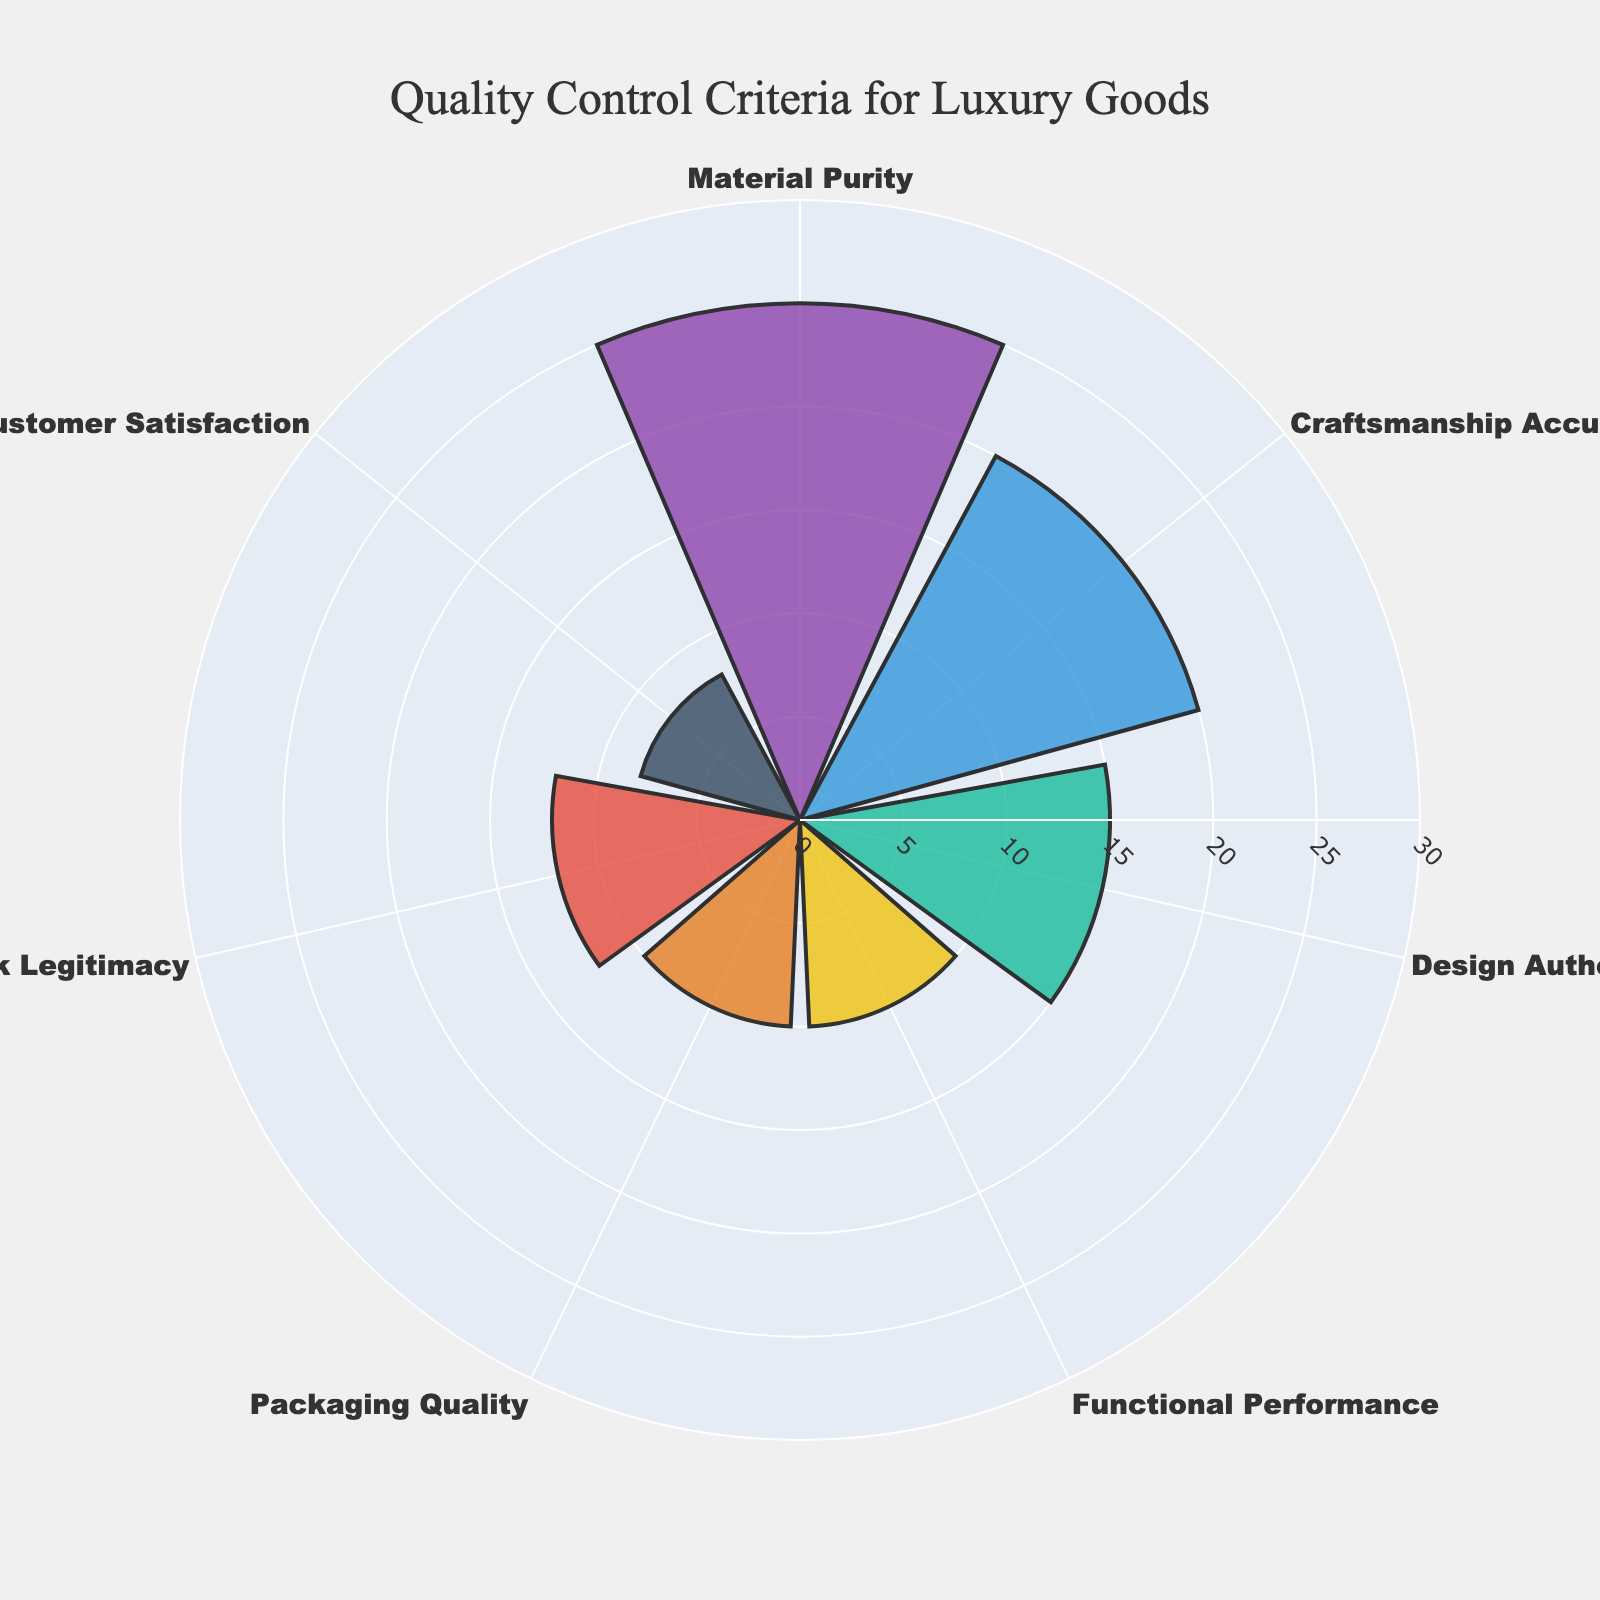What's the title of the figure? The title is located at the top of the chart in a larger, bold font.
Answer: Quality Control Criteria for Luxury Goods How many categories are displayed in the chart? By counting the number of distinct sections (or bars) around the chart, you can see there are 7 categories.
Answer: 7 Which category has the highest proportion? Look for the bar that extends the furthest from the center. Material Purity reaches the highest point.
Answer: Material Purity What's the proportion for Customer Satisfaction? Locate the section labeled "Customer Satisfaction." The number written near its endpoint is 8%.
Answer: 8% What is the combined proportion for Craftsmanship Accuracy and Functional Performance? Identify the proportions for both Craftsmanship Accuracy (20) and Functional Performance (10), then sum them up: 20 + 10 = 30.
Answer: 30 How does Packaging Quality's proportion compare to Brand Mark Legitimacy's? Compare the lengths of the bars for Packaging Quality and Brand Mark Legitimacy. Packaging Quality is 10% and Brand Mark Legitimacy is 12%, so Packaging Quality is lower.
Answer: Lower Which category has the smallest proportion, and what is its value? Find the shortest bar in the chart. Customer Satisfaction has the smallest proportion with a value of 8%.
Answer: Customer Satisfaction, 8% If Design Authenticity's proportion increased by 10%, what would its new value be? Design Authenticity currently is at 15%. Adding 10% results in: 15 + 10 = 25.
Answer: 25 What's the difference between the proportions of Material Purity and Design Authenticity? Material Purity has a proportion of 25, and Design Authenticity has 15. Subtract the smaller from the larger: 25 - 15 = 10.
Answer: 10 Which categories combined have a total proportion equal to that of Material Purity? Material Purity is 25%. Craftsmanship Accuracy (20%) and Customer Satisfaction (5%) or Functional Performance (10%) and Brand Mark Legitimacy (12%) sum to 25.
Answer: Craftsmanship Accuracy and Customer Satisfaction 